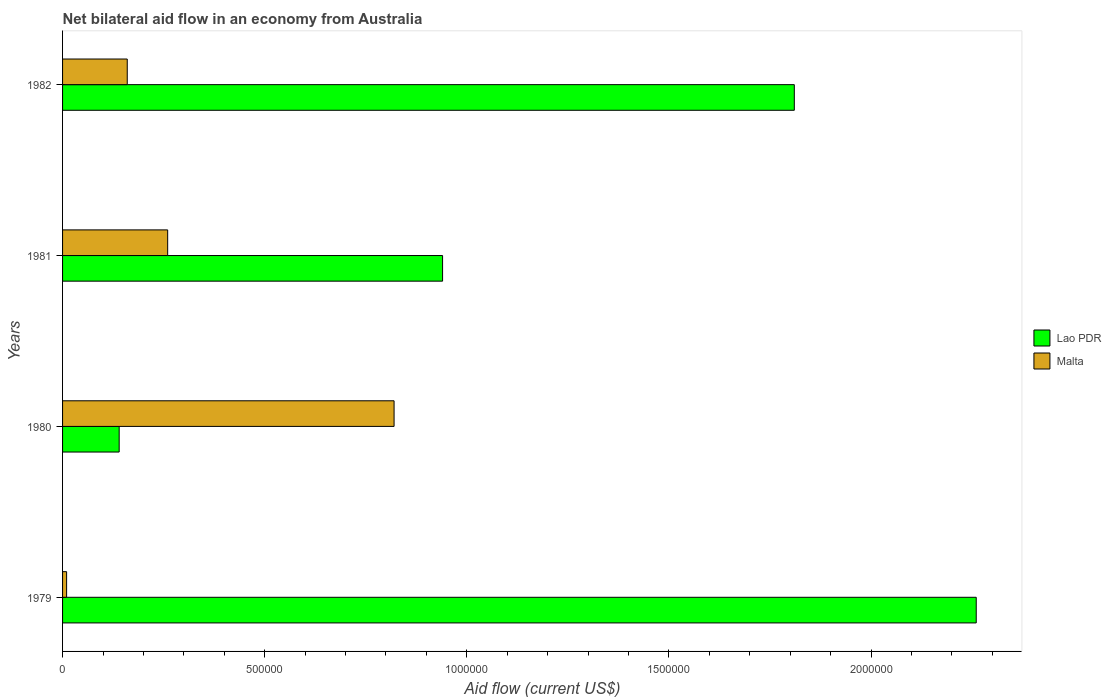How many different coloured bars are there?
Offer a very short reply. 2. Are the number of bars on each tick of the Y-axis equal?
Give a very brief answer. Yes. How many bars are there on the 3rd tick from the bottom?
Offer a terse response. 2. Across all years, what is the maximum net bilateral aid flow in Lao PDR?
Provide a succinct answer. 2.26e+06. Across all years, what is the minimum net bilateral aid flow in Malta?
Make the answer very short. 10000. In which year was the net bilateral aid flow in Lao PDR maximum?
Give a very brief answer. 1979. In which year was the net bilateral aid flow in Malta minimum?
Offer a very short reply. 1979. What is the total net bilateral aid flow in Lao PDR in the graph?
Keep it short and to the point. 5.15e+06. What is the difference between the net bilateral aid flow in Lao PDR in 1979 and that in 1980?
Offer a very short reply. 2.12e+06. What is the average net bilateral aid flow in Malta per year?
Offer a very short reply. 3.12e+05. In the year 1979, what is the difference between the net bilateral aid flow in Malta and net bilateral aid flow in Lao PDR?
Your response must be concise. -2.25e+06. What is the ratio of the net bilateral aid flow in Lao PDR in 1979 to that in 1980?
Provide a short and direct response. 16.14. Is the net bilateral aid flow in Lao PDR in 1980 less than that in 1982?
Keep it short and to the point. Yes. What is the difference between the highest and the second highest net bilateral aid flow in Malta?
Offer a very short reply. 5.60e+05. What is the difference between the highest and the lowest net bilateral aid flow in Lao PDR?
Your answer should be very brief. 2.12e+06. Is the sum of the net bilateral aid flow in Malta in 1980 and 1981 greater than the maximum net bilateral aid flow in Lao PDR across all years?
Make the answer very short. No. What does the 1st bar from the top in 1982 represents?
Provide a succinct answer. Malta. What does the 2nd bar from the bottom in 1980 represents?
Keep it short and to the point. Malta. How many bars are there?
Your answer should be very brief. 8. How many years are there in the graph?
Ensure brevity in your answer.  4. What is the difference between two consecutive major ticks on the X-axis?
Ensure brevity in your answer.  5.00e+05. Does the graph contain grids?
Offer a very short reply. No. Where does the legend appear in the graph?
Offer a terse response. Center right. What is the title of the graph?
Give a very brief answer. Net bilateral aid flow in an economy from Australia. What is the label or title of the X-axis?
Provide a succinct answer. Aid flow (current US$). What is the label or title of the Y-axis?
Your answer should be compact. Years. What is the Aid flow (current US$) in Lao PDR in 1979?
Provide a succinct answer. 2.26e+06. What is the Aid flow (current US$) in Malta in 1979?
Your response must be concise. 10000. What is the Aid flow (current US$) of Malta in 1980?
Provide a succinct answer. 8.20e+05. What is the Aid flow (current US$) of Lao PDR in 1981?
Provide a short and direct response. 9.40e+05. What is the Aid flow (current US$) in Lao PDR in 1982?
Make the answer very short. 1.81e+06. What is the Aid flow (current US$) of Malta in 1982?
Provide a short and direct response. 1.60e+05. Across all years, what is the maximum Aid flow (current US$) of Lao PDR?
Keep it short and to the point. 2.26e+06. Across all years, what is the maximum Aid flow (current US$) in Malta?
Give a very brief answer. 8.20e+05. Across all years, what is the minimum Aid flow (current US$) in Lao PDR?
Provide a short and direct response. 1.40e+05. What is the total Aid flow (current US$) in Lao PDR in the graph?
Provide a succinct answer. 5.15e+06. What is the total Aid flow (current US$) of Malta in the graph?
Offer a very short reply. 1.25e+06. What is the difference between the Aid flow (current US$) of Lao PDR in 1979 and that in 1980?
Your answer should be compact. 2.12e+06. What is the difference between the Aid flow (current US$) in Malta in 1979 and that in 1980?
Provide a succinct answer. -8.10e+05. What is the difference between the Aid flow (current US$) of Lao PDR in 1979 and that in 1981?
Provide a succinct answer. 1.32e+06. What is the difference between the Aid flow (current US$) of Malta in 1979 and that in 1981?
Provide a succinct answer. -2.50e+05. What is the difference between the Aid flow (current US$) of Malta in 1979 and that in 1982?
Ensure brevity in your answer.  -1.50e+05. What is the difference between the Aid flow (current US$) of Lao PDR in 1980 and that in 1981?
Your answer should be compact. -8.00e+05. What is the difference between the Aid flow (current US$) in Malta in 1980 and that in 1981?
Your answer should be compact. 5.60e+05. What is the difference between the Aid flow (current US$) in Lao PDR in 1980 and that in 1982?
Offer a terse response. -1.67e+06. What is the difference between the Aid flow (current US$) in Malta in 1980 and that in 1982?
Your response must be concise. 6.60e+05. What is the difference between the Aid flow (current US$) of Lao PDR in 1981 and that in 1982?
Your answer should be compact. -8.70e+05. What is the difference between the Aid flow (current US$) of Malta in 1981 and that in 1982?
Keep it short and to the point. 1.00e+05. What is the difference between the Aid flow (current US$) of Lao PDR in 1979 and the Aid flow (current US$) of Malta in 1980?
Keep it short and to the point. 1.44e+06. What is the difference between the Aid flow (current US$) of Lao PDR in 1979 and the Aid flow (current US$) of Malta in 1982?
Make the answer very short. 2.10e+06. What is the difference between the Aid flow (current US$) of Lao PDR in 1980 and the Aid flow (current US$) of Malta in 1982?
Your answer should be compact. -2.00e+04. What is the difference between the Aid flow (current US$) in Lao PDR in 1981 and the Aid flow (current US$) in Malta in 1982?
Give a very brief answer. 7.80e+05. What is the average Aid flow (current US$) of Lao PDR per year?
Provide a succinct answer. 1.29e+06. What is the average Aid flow (current US$) in Malta per year?
Your answer should be compact. 3.12e+05. In the year 1979, what is the difference between the Aid flow (current US$) in Lao PDR and Aid flow (current US$) in Malta?
Provide a short and direct response. 2.25e+06. In the year 1980, what is the difference between the Aid flow (current US$) in Lao PDR and Aid flow (current US$) in Malta?
Your response must be concise. -6.80e+05. In the year 1981, what is the difference between the Aid flow (current US$) in Lao PDR and Aid flow (current US$) in Malta?
Give a very brief answer. 6.80e+05. In the year 1982, what is the difference between the Aid flow (current US$) in Lao PDR and Aid flow (current US$) in Malta?
Keep it short and to the point. 1.65e+06. What is the ratio of the Aid flow (current US$) of Lao PDR in 1979 to that in 1980?
Give a very brief answer. 16.14. What is the ratio of the Aid flow (current US$) of Malta in 1979 to that in 1980?
Ensure brevity in your answer.  0.01. What is the ratio of the Aid flow (current US$) in Lao PDR in 1979 to that in 1981?
Offer a very short reply. 2.4. What is the ratio of the Aid flow (current US$) of Malta in 1979 to that in 1981?
Offer a very short reply. 0.04. What is the ratio of the Aid flow (current US$) in Lao PDR in 1979 to that in 1982?
Your answer should be very brief. 1.25. What is the ratio of the Aid flow (current US$) of Malta in 1979 to that in 1982?
Offer a very short reply. 0.06. What is the ratio of the Aid flow (current US$) of Lao PDR in 1980 to that in 1981?
Provide a succinct answer. 0.15. What is the ratio of the Aid flow (current US$) of Malta in 1980 to that in 1981?
Give a very brief answer. 3.15. What is the ratio of the Aid flow (current US$) of Lao PDR in 1980 to that in 1982?
Ensure brevity in your answer.  0.08. What is the ratio of the Aid flow (current US$) of Malta in 1980 to that in 1982?
Keep it short and to the point. 5.12. What is the ratio of the Aid flow (current US$) of Lao PDR in 1981 to that in 1982?
Offer a very short reply. 0.52. What is the ratio of the Aid flow (current US$) in Malta in 1981 to that in 1982?
Your answer should be compact. 1.62. What is the difference between the highest and the second highest Aid flow (current US$) of Lao PDR?
Your answer should be very brief. 4.50e+05. What is the difference between the highest and the second highest Aid flow (current US$) of Malta?
Give a very brief answer. 5.60e+05. What is the difference between the highest and the lowest Aid flow (current US$) in Lao PDR?
Your answer should be very brief. 2.12e+06. What is the difference between the highest and the lowest Aid flow (current US$) of Malta?
Provide a short and direct response. 8.10e+05. 